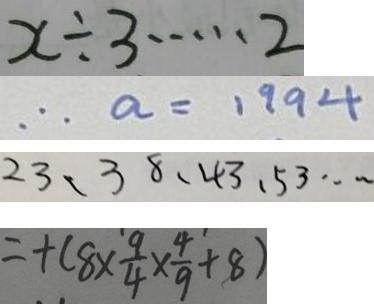Convert formula to latex. <formula><loc_0><loc_0><loc_500><loc_500>x \div 3 \cdots 2 
 \therefore a = 1 9 9 4 
 2 3 、 3 8 、 4 3 、 5 3 \cdots 
 = + ( 8 \times \frac { 9 } { 4 } \times \frac { 4 } { 9 } + 8 )</formula> 